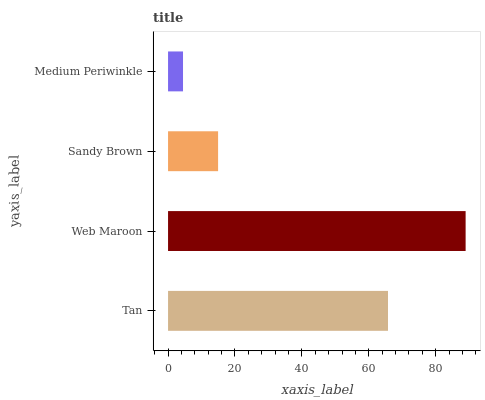Is Medium Periwinkle the minimum?
Answer yes or no. Yes. Is Web Maroon the maximum?
Answer yes or no. Yes. Is Sandy Brown the minimum?
Answer yes or no. No. Is Sandy Brown the maximum?
Answer yes or no. No. Is Web Maroon greater than Sandy Brown?
Answer yes or no. Yes. Is Sandy Brown less than Web Maroon?
Answer yes or no. Yes. Is Sandy Brown greater than Web Maroon?
Answer yes or no. No. Is Web Maroon less than Sandy Brown?
Answer yes or no. No. Is Tan the high median?
Answer yes or no. Yes. Is Sandy Brown the low median?
Answer yes or no. Yes. Is Sandy Brown the high median?
Answer yes or no. No. Is Web Maroon the low median?
Answer yes or no. No. 